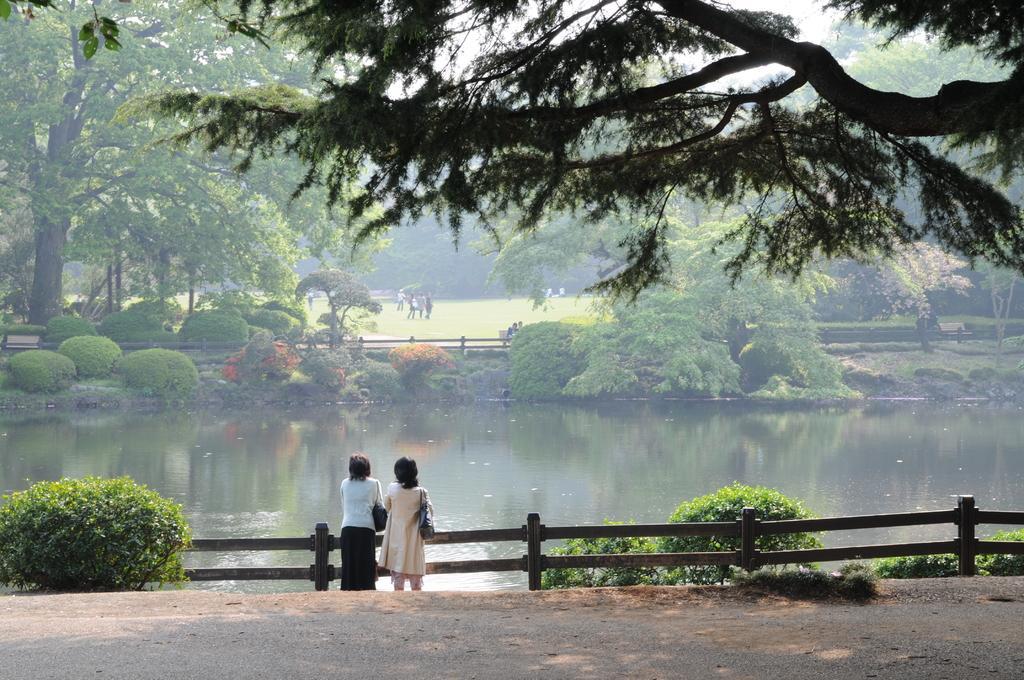Describe this image in one or two sentences. In this picture we can see two women wearing bags and standing on the path. There is a plant on the left side. We can see a wooden fence from left to right. There is water. We can see a few people and trees in the background. 